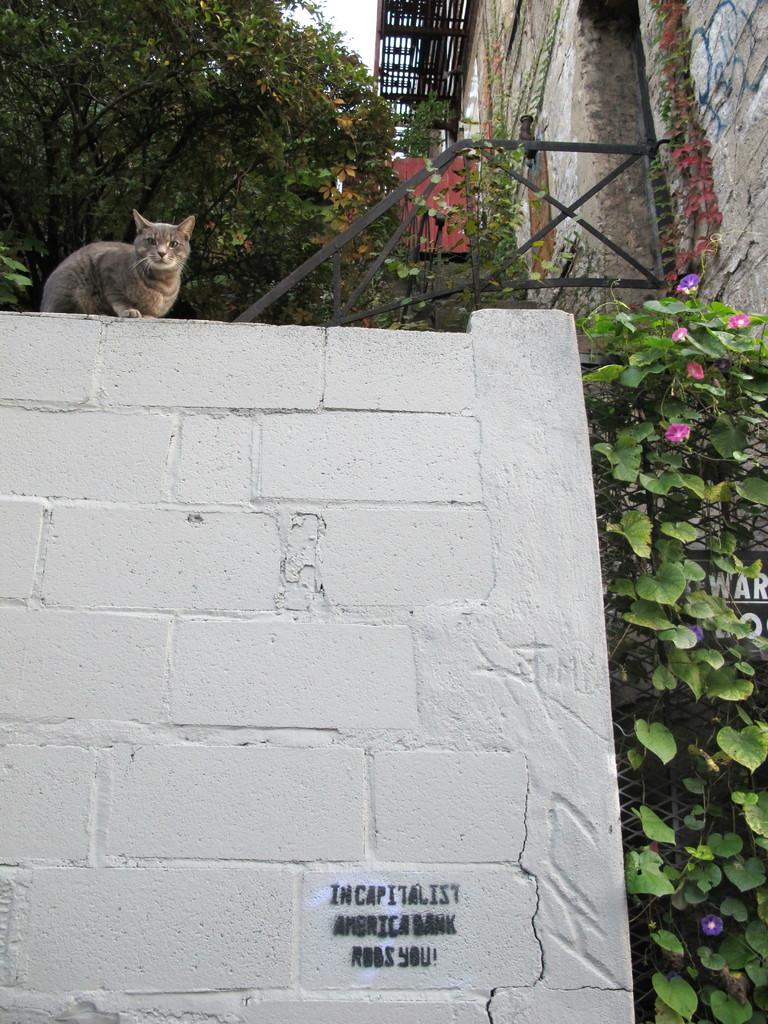What is the color of the wall in the image? The wall in the image is white. What is sitting on the wall? A cat is sitting on the wall. What can be seen on the right side of the image? There are green color leaves on the right side of the image. What team is playing a surprise game of recess in the image? There is no team or game of recess present in the image; it features a white wall with a cat sitting on it and green leaves on the right side. 